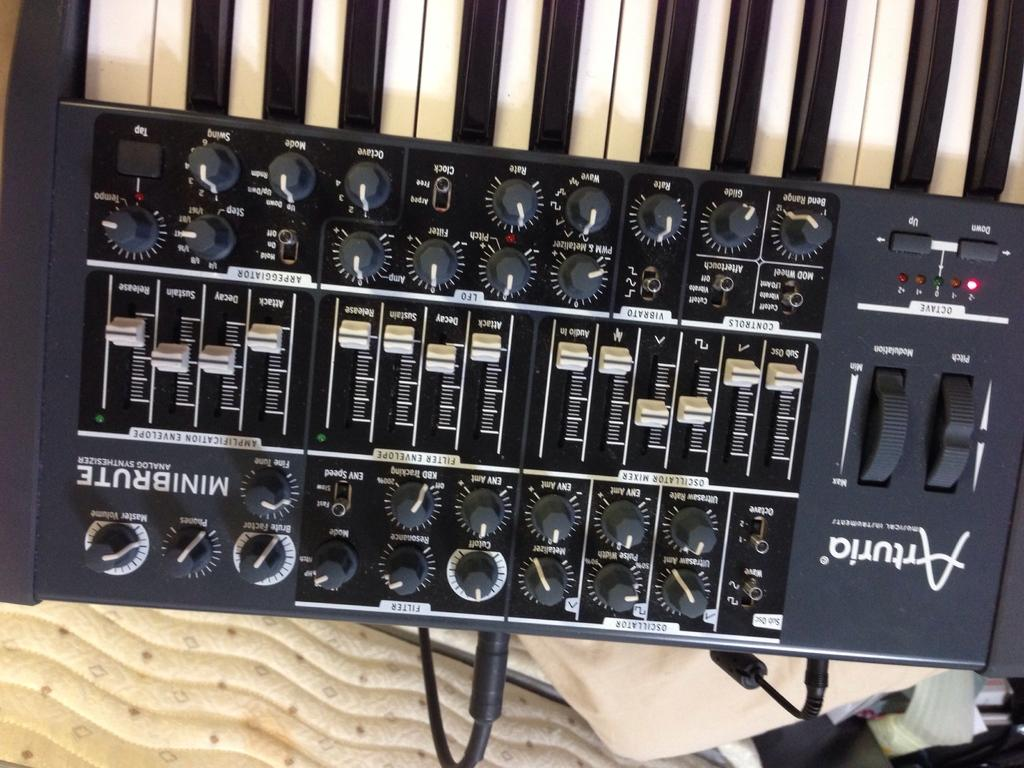What is the main object in the picture? There is a piano in the picture. What are the keys on the piano used for? The different keys on the piano are used for playing music. What else can be seen on the piano besides the keys? There are many buttons on the piano. Is there anything connected to the piano in the picture? Yes, the piano has a cable attached to it. What type of office equipment is present in the image? There is no office equipment present in the image; it features a piano. What activity is taking place in the image? The image does not show any activity taking place; it simply shows a piano with keys, buttons, and a cable attached to it. 